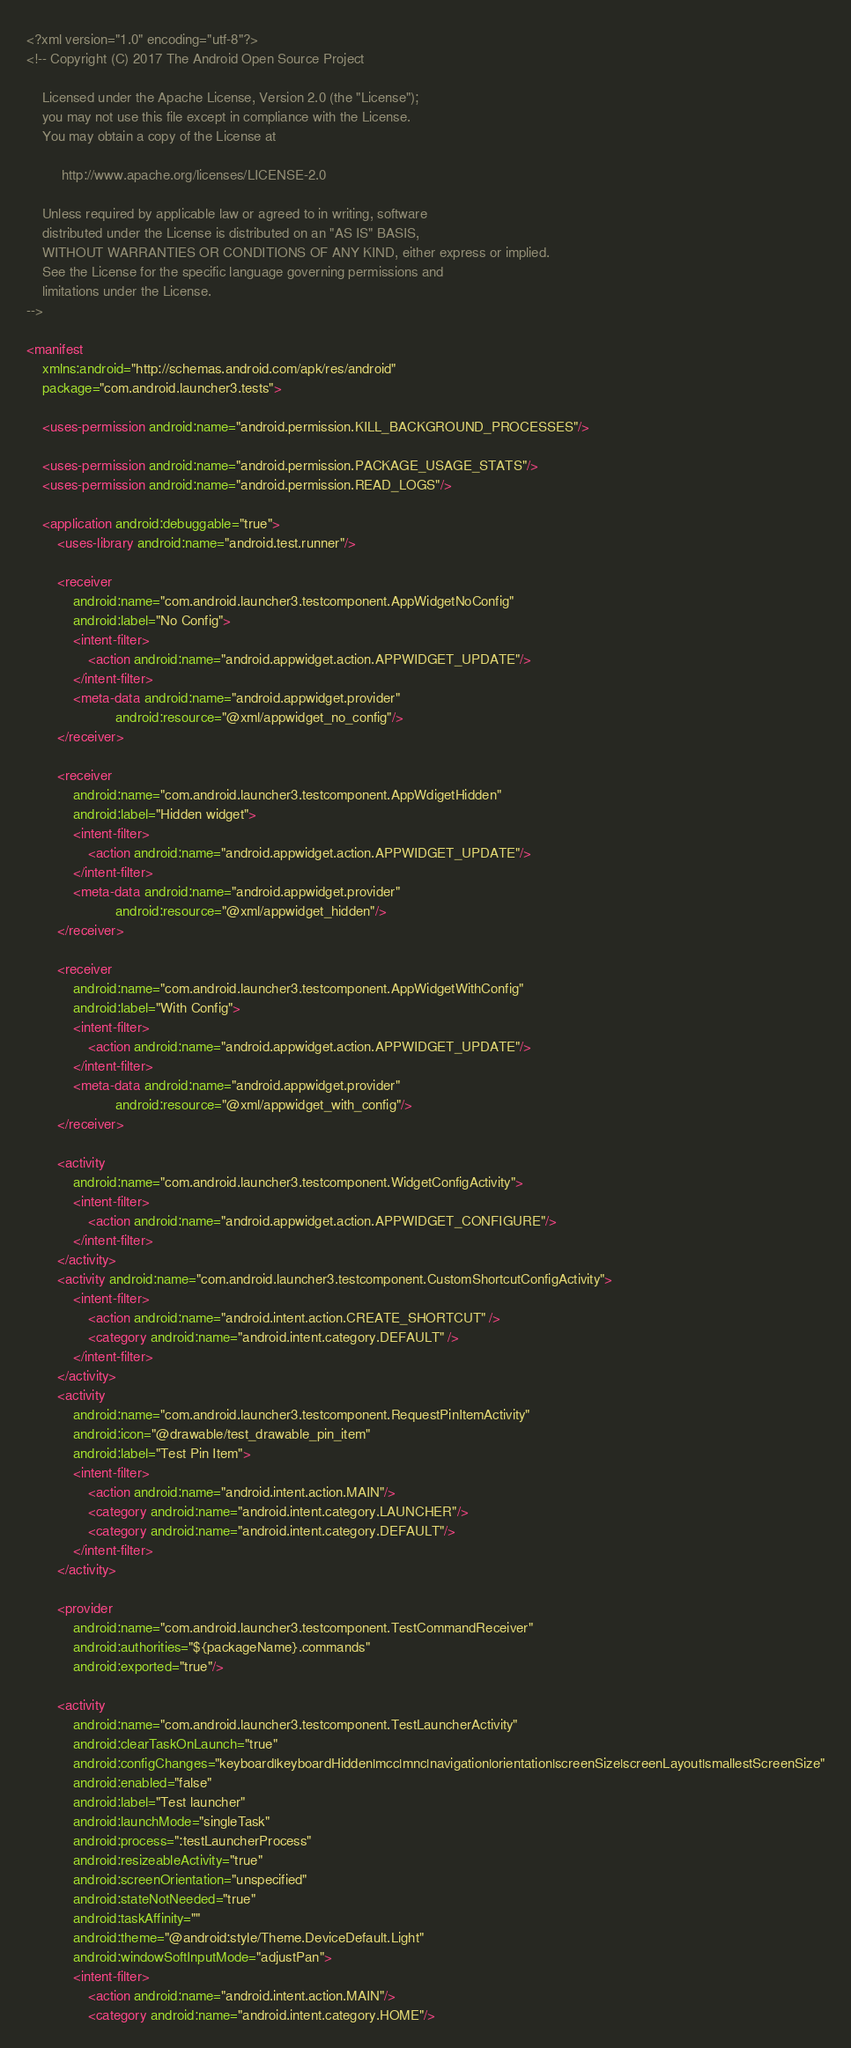Convert code to text. <code><loc_0><loc_0><loc_500><loc_500><_XML_><?xml version="1.0" encoding="utf-8"?>
<!-- Copyright (C) 2017 The Android Open Source Project

    Licensed under the Apache License, Version 2.0 (the "License");
    you may not use this file except in compliance with the License.
    You may obtain a copy of the License at

         http://www.apache.org/licenses/LICENSE-2.0

    Unless required by applicable law or agreed to in writing, software
    distributed under the License is distributed on an "AS IS" BASIS,
    WITHOUT WARRANTIES OR CONDITIONS OF ANY KIND, either express or implied.
    See the License for the specific language governing permissions and
    limitations under the License.
-->

<manifest
    xmlns:android="http://schemas.android.com/apk/res/android"
    package="com.android.launcher3.tests">

    <uses-permission android:name="android.permission.KILL_BACKGROUND_PROCESSES"/>

    <uses-permission android:name="android.permission.PACKAGE_USAGE_STATS"/>
    <uses-permission android:name="android.permission.READ_LOGS"/>

    <application android:debuggable="true">
        <uses-library android:name="android.test.runner"/>

        <receiver
            android:name="com.android.launcher3.testcomponent.AppWidgetNoConfig"
            android:label="No Config">
            <intent-filter>
                <action android:name="android.appwidget.action.APPWIDGET_UPDATE"/>
            </intent-filter>
            <meta-data android:name="android.appwidget.provider"
                       android:resource="@xml/appwidget_no_config"/>
        </receiver>

        <receiver
            android:name="com.android.launcher3.testcomponent.AppWdigetHidden"
            android:label="Hidden widget">
            <intent-filter>
                <action android:name="android.appwidget.action.APPWIDGET_UPDATE"/>
            </intent-filter>
            <meta-data android:name="android.appwidget.provider"
                       android:resource="@xml/appwidget_hidden"/>
        </receiver>

        <receiver
            android:name="com.android.launcher3.testcomponent.AppWidgetWithConfig"
            android:label="With Config">
            <intent-filter>
                <action android:name="android.appwidget.action.APPWIDGET_UPDATE"/>
            </intent-filter>
            <meta-data android:name="android.appwidget.provider"
                       android:resource="@xml/appwidget_with_config"/>
        </receiver>

        <activity
            android:name="com.android.launcher3.testcomponent.WidgetConfigActivity">
            <intent-filter>
                <action android:name="android.appwidget.action.APPWIDGET_CONFIGURE"/>
            </intent-filter>
        </activity>
        <activity android:name="com.android.launcher3.testcomponent.CustomShortcutConfigActivity">
            <intent-filter>
                <action android:name="android.intent.action.CREATE_SHORTCUT" />
                <category android:name="android.intent.category.DEFAULT" />
            </intent-filter>
        </activity>
        <activity
            android:name="com.android.launcher3.testcomponent.RequestPinItemActivity"
            android:icon="@drawable/test_drawable_pin_item"
            android:label="Test Pin Item">
            <intent-filter>
                <action android:name="android.intent.action.MAIN"/>
                <category android:name="android.intent.category.LAUNCHER"/>
                <category android:name="android.intent.category.DEFAULT"/>
            </intent-filter>
        </activity>

        <provider
            android:name="com.android.launcher3.testcomponent.TestCommandReceiver"
            android:authorities="${packageName}.commands"
            android:exported="true"/>

        <activity
            android:name="com.android.launcher3.testcomponent.TestLauncherActivity"
            android:clearTaskOnLaunch="true"
            android:configChanges="keyboard|keyboardHidden|mcc|mnc|navigation|orientation|screenSize|screenLayout|smallestScreenSize"
            android:enabled="false"
            android:label="Test launcher"
            android:launchMode="singleTask"
            android:process=":testLauncherProcess"
            android:resizeableActivity="true"
            android:screenOrientation="unspecified"
            android:stateNotNeeded="true"
            android:taskAffinity=""
            android:theme="@android:style/Theme.DeviceDefault.Light"
            android:windowSoftInputMode="adjustPan">
            <intent-filter>
                <action android:name="android.intent.action.MAIN"/>
                <category android:name="android.intent.category.HOME"/></code> 